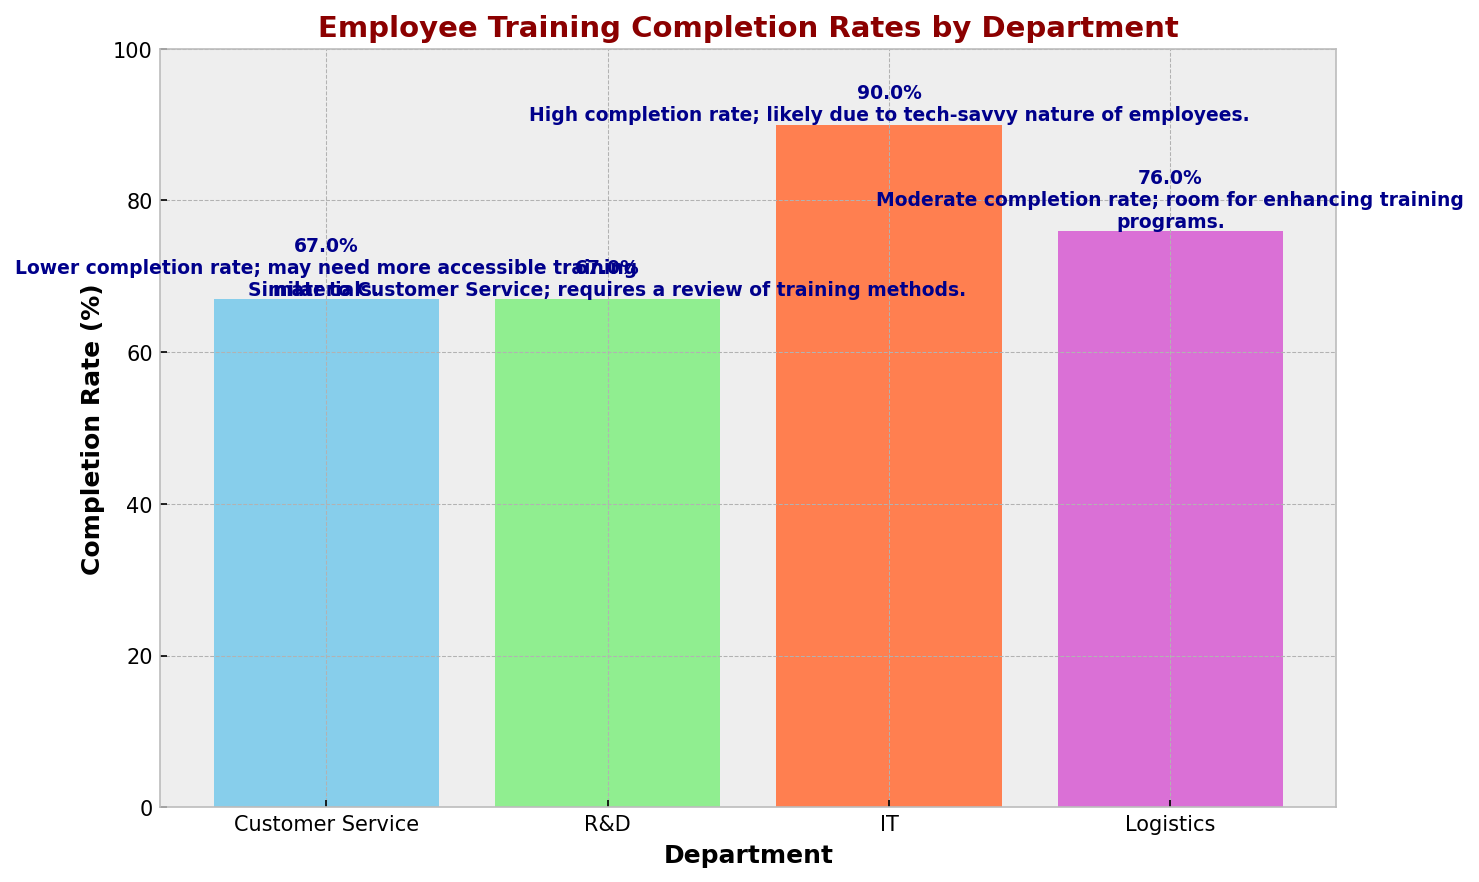What is the completion rate for the IT department? The IT department's bar shows a height of 90%, and the annotation directly states "90%".
Answer: 90% Which department has the highest completion rate? By comparing the heights of all bars, the IT department's bar is the tallest, indicating the highest completion rate.
Answer: IT How does the completion rate of the Customer Service department compare to that of the Logistics department? The Customer Service department has a 67% completion rate, while the Logistics department has a 76% completion rate. The Logistics department has a higher completion rate.
Answer: Logistics has a higher rate What is the average completion rate across all departments? Summing up the completion rates: 67% (Customer Service) + 67% (R&D) + 90% (IT) + 76% (Logistics) = 300%. Dividing by the number of departments (4) gives an average completion rate of 75%.
Answer: 75% Which department requires a review of training methods according to the key insights? The annotation for the R&D department explicitly states "requires a review of training methods".
Answer: R&D What is the difference in completion rates between the department with the highest and the lowest rates? The IT department has the highest rate at 90%, and both the Customer Service and R&D departments have the lowest rate at 67%. The difference is 90% - 67% = 23%.
Answer: 23% Identify a department with a moderate completion rate and its particular area of improvement. Logistics is identified with a moderate completion rate of 76%, and its key insight suggests "room for enhancing training programs".
Answer: Logistics, enhancing training programs What is the combined number of employees who completed training in the Customer Service and R&D departments? Customer Service has 20 employees who completed training, and R&D has 10, summing to 20 + 10 = 30 employees.
Answer: 30 How does the completion rate of tech-savvy employees in IT compare to the overall average completion rate? The IT department has a 90% completion rate. The overall average completion rate is 75%. The IT department's rate is higher by 15%.
Answer: 15% higher Which department has key insights suggesting the need for more accessible training materials? The annotation for the Customer Service department states "may need more accessible training materials".
Answer: Customer Service 